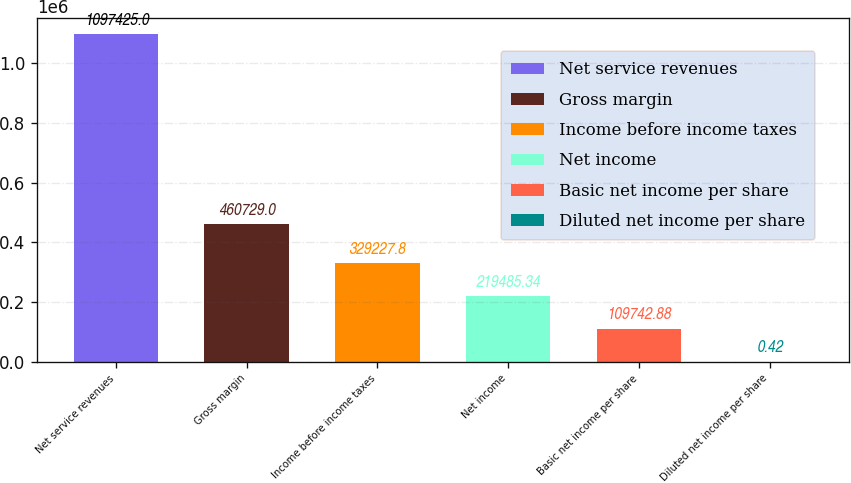Convert chart to OTSL. <chart><loc_0><loc_0><loc_500><loc_500><bar_chart><fcel>Net service revenues<fcel>Gross margin<fcel>Income before income taxes<fcel>Net income<fcel>Basic net income per share<fcel>Diluted net income per share<nl><fcel>1.09742e+06<fcel>460729<fcel>329228<fcel>219485<fcel>109743<fcel>0.42<nl></chart> 